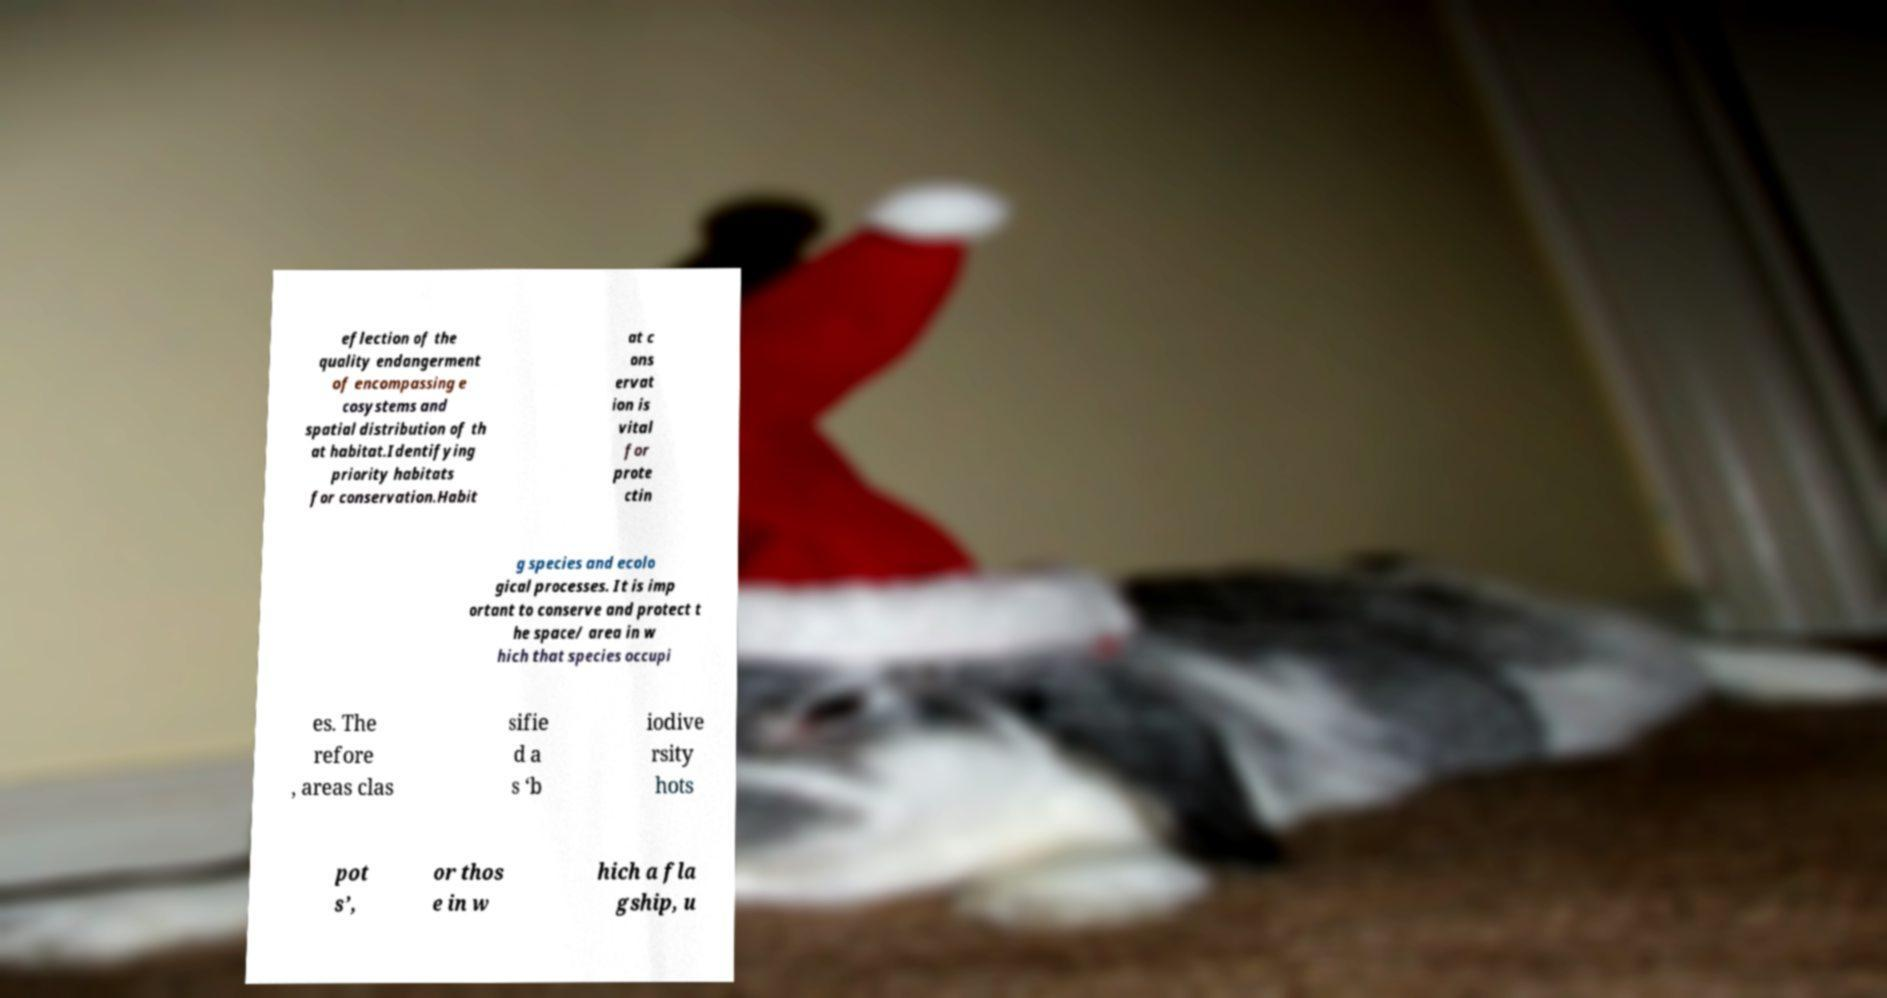I need the written content from this picture converted into text. Can you do that? eflection of the quality endangerment of encompassing e cosystems and spatial distribution of th at habitat.Identifying priority habitats for conservation.Habit at c ons ervat ion is vital for prote ctin g species and ecolo gical processes. It is imp ortant to conserve and protect t he space/ area in w hich that species occupi es. The refore , areas clas sifie d a s ‘b iodive rsity hots pot s’, or thos e in w hich a fla gship, u 